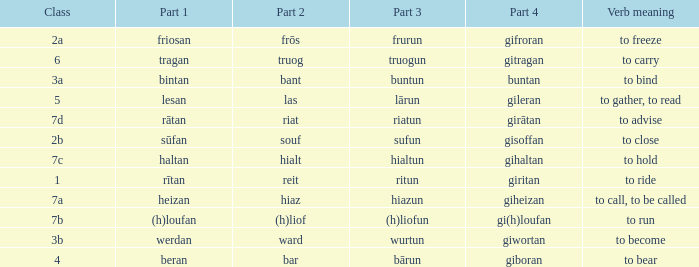What is the part 3 of the word in class 7a? Hiazun. 